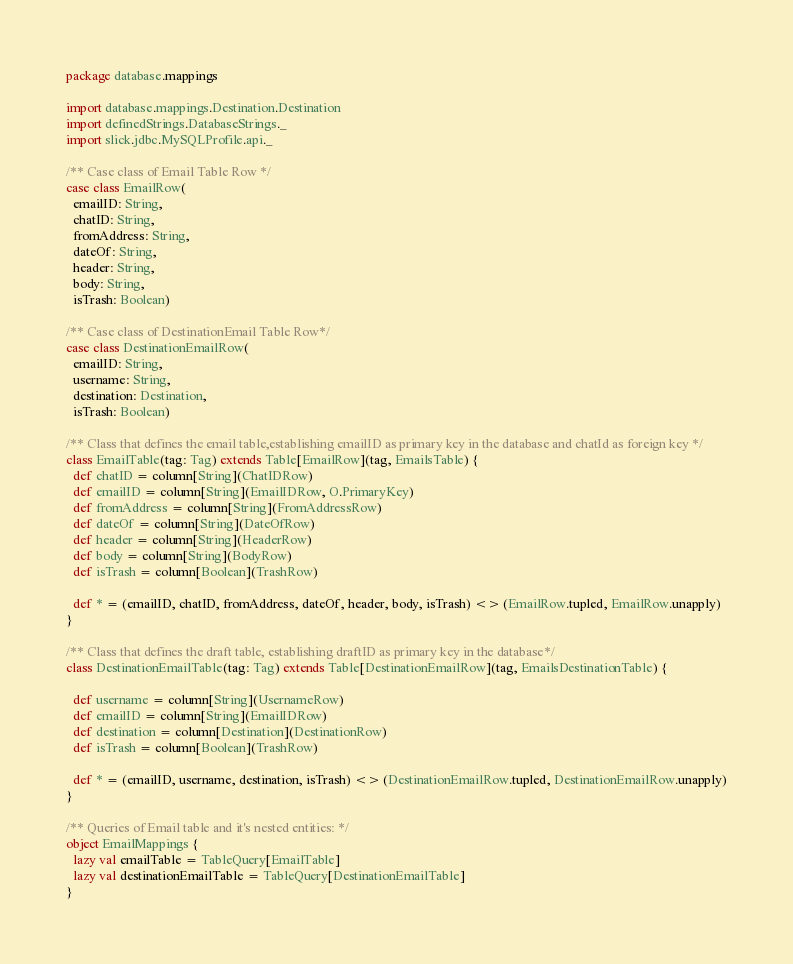Convert code to text. <code><loc_0><loc_0><loc_500><loc_500><_Scala_>package database.mappings

import database.mappings.Destination.Destination
import definedStrings.DatabaseStrings._
import slick.jdbc.MySQLProfile.api._

/** Case class of Email Table Row */
case class EmailRow(
  emailID: String,
  chatID: String,
  fromAddress: String,
  dateOf: String,
  header: String,
  body: String,
  isTrash: Boolean)

/** Case class of DestinationEmail Table Row*/
case class DestinationEmailRow(
  emailID: String,
  username: String,
  destination: Destination,
  isTrash: Boolean)

/** Class that defines the email table,establishing emailID as primary key in the database and chatId as foreign key */
class EmailTable(tag: Tag) extends Table[EmailRow](tag, EmailsTable) {
  def chatID = column[String](ChatIDRow)
  def emailID = column[String](EmailIDRow, O.PrimaryKey)
  def fromAddress = column[String](FromAddressRow)
  def dateOf = column[String](DateOfRow)
  def header = column[String](HeaderRow)
  def body = column[String](BodyRow)
  def isTrash = column[Boolean](TrashRow)

  def * = (emailID, chatID, fromAddress, dateOf, header, body, isTrash) <> (EmailRow.tupled, EmailRow.unapply)
}

/** Class that defines the draft table, establishing draftID as primary key in the database*/
class DestinationEmailTable(tag: Tag) extends Table[DestinationEmailRow](tag, EmailsDestinationTable) {

  def username = column[String](UsernameRow)
  def emailID = column[String](EmailIDRow)
  def destination = column[Destination](DestinationRow)
  def isTrash = column[Boolean](TrashRow)

  def * = (emailID, username, destination, isTrash) <> (DestinationEmailRow.tupled, DestinationEmailRow.unapply)
}

/** Queries of Email table and it's nested entities: */
object EmailMappings {
  lazy val emailTable = TableQuery[EmailTable]
  lazy val destinationEmailTable = TableQuery[DestinationEmailTable]
}
</code> 